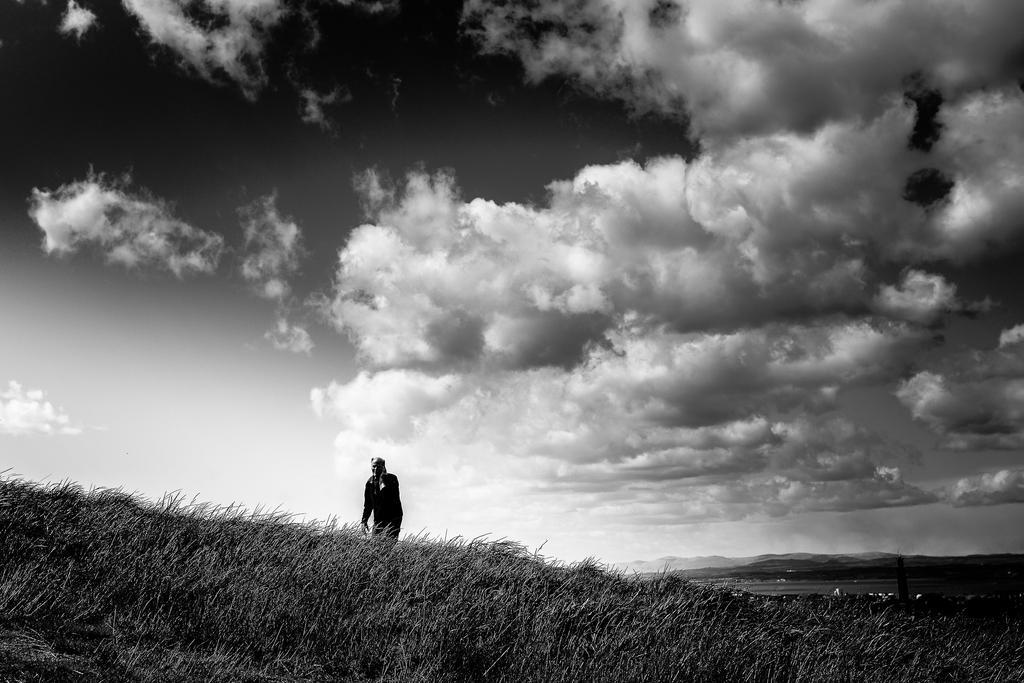What type of vegetation is present in the image? There is grass in the image. Can you describe the person in the image? There is a person in the image. What can be seen in the background of the image? The background of the image includes clouds in the sky. What is the color scheme of the image? The image is in black and white. What type of stocking is the person wearing in the image? There is no stocking visible in the image, as it is in black and white and does not show any clothing details. 